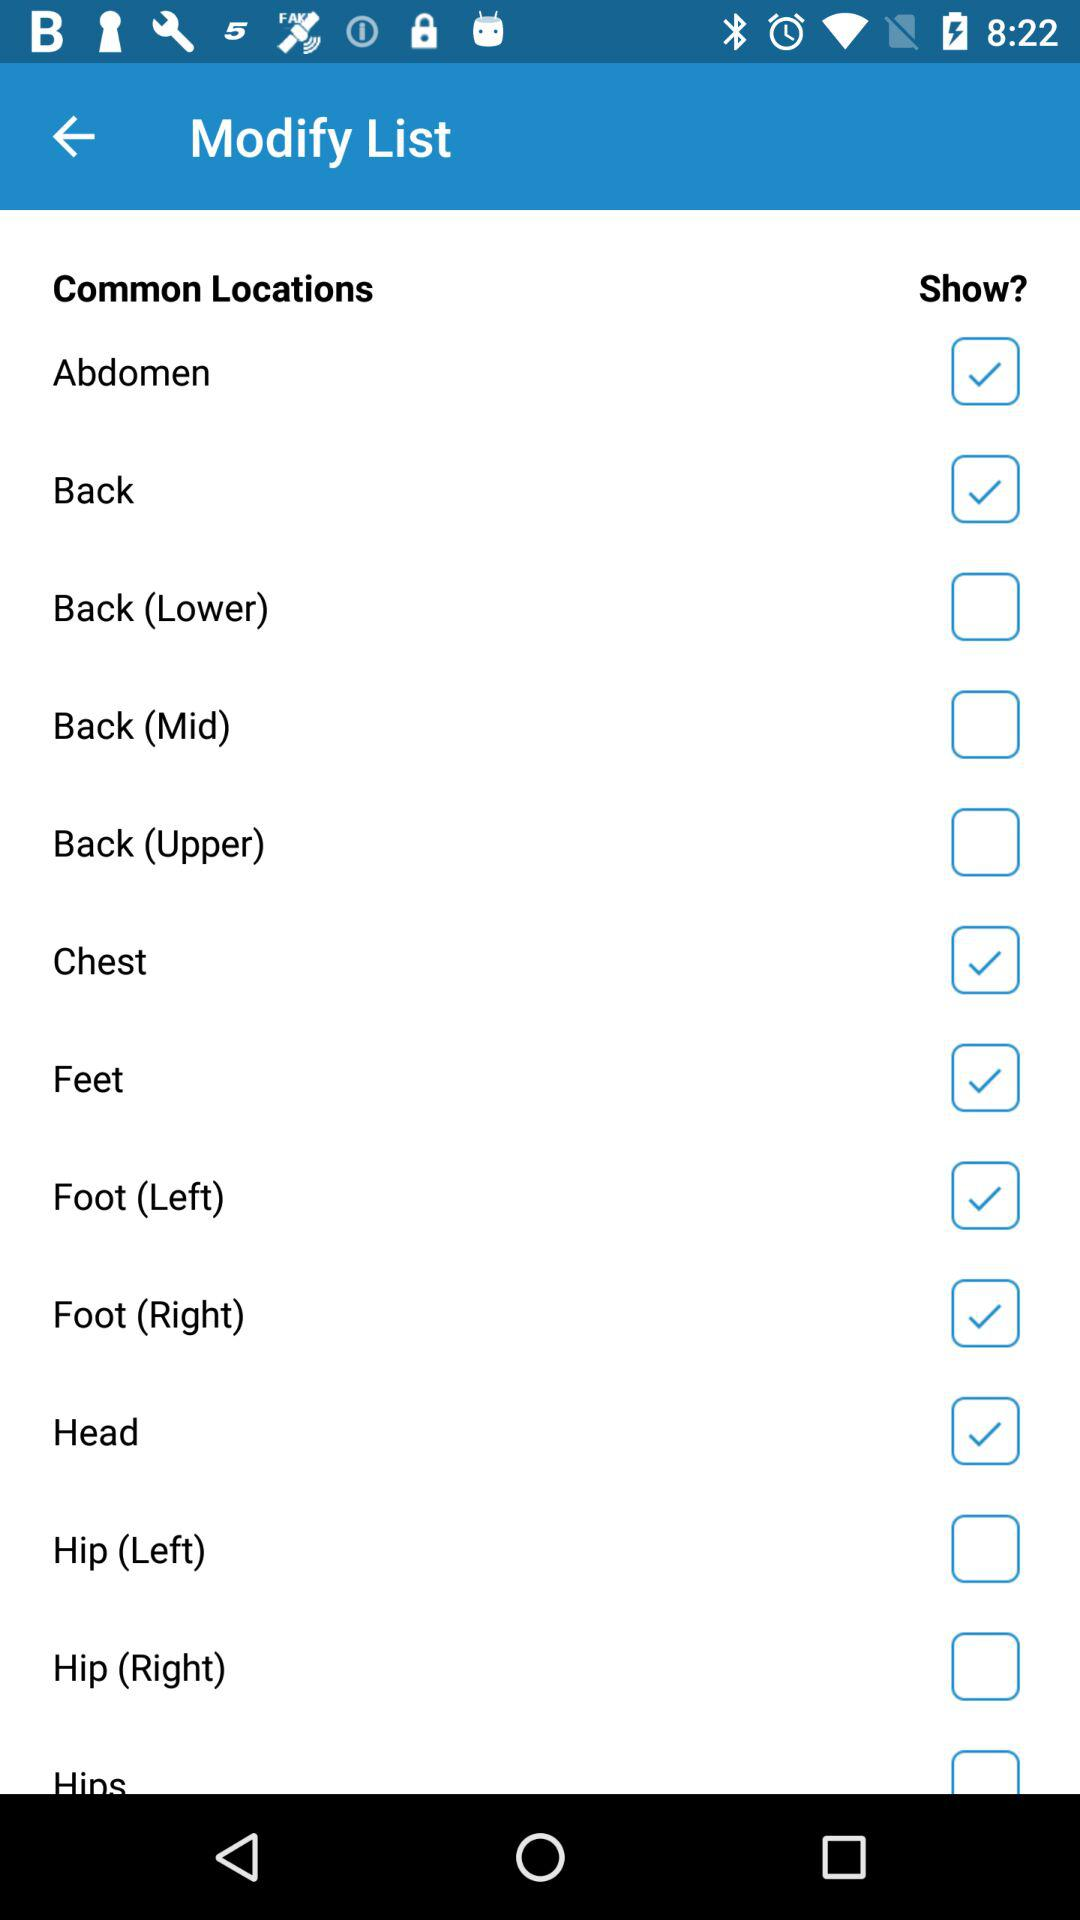Which option is marked as checked? The options that are marked as checked are "Abdomen", "Back", "Chest", "Feet", "Foot (Left)", "Foot (Right)" and "Head". 